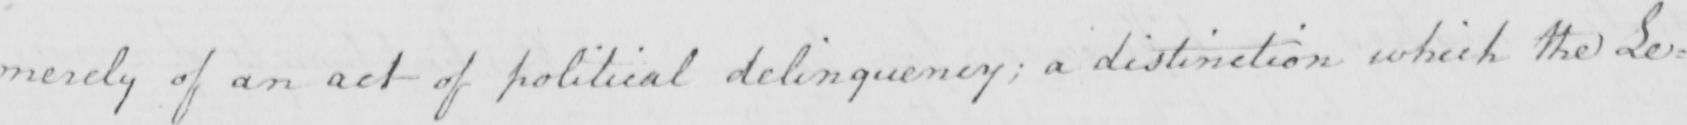Can you read and transcribe this handwriting? merely of an act of political delinquency ; a distinction which the Le= 